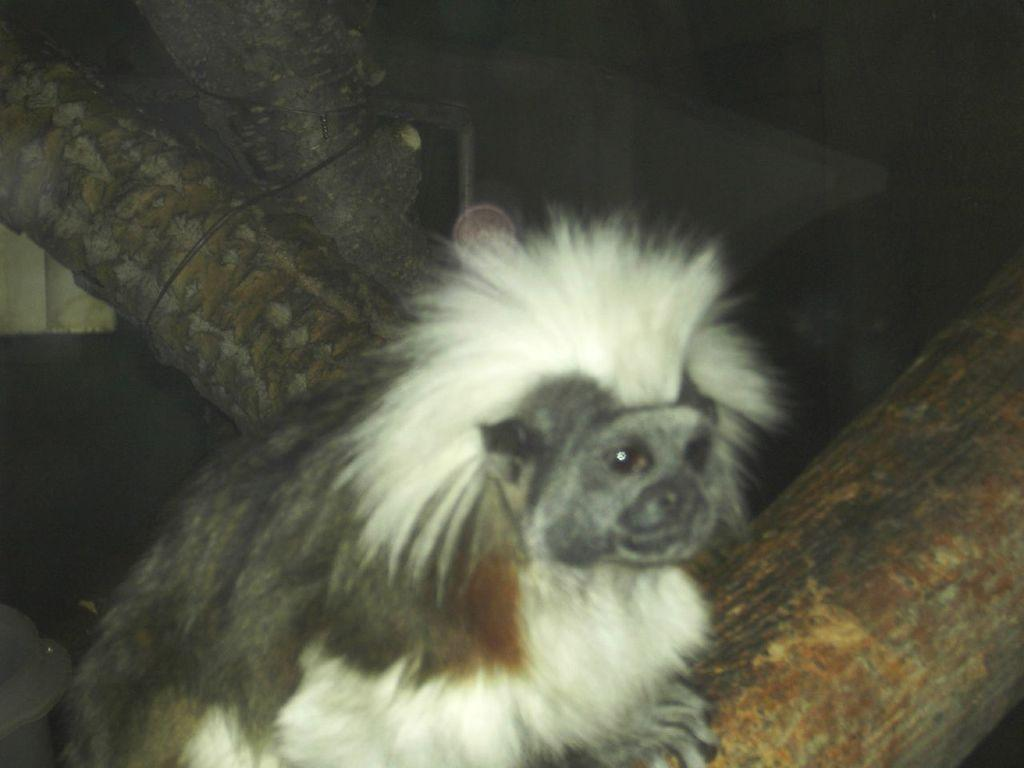What type of animal is in the image? There is a marmoset in the image. What is the color of the background in the image? The background of the image is dark. What can be seen on the left side of the image? There appears to be a branch of a tree on the left side of the image. What type of linen is draped over the marmoset in the image? There is no linen present in the image; the marmoset is not covered by any fabric. What is the marmoset's interest in the image? The image does not provide information about the marmoset's interests or activities. 